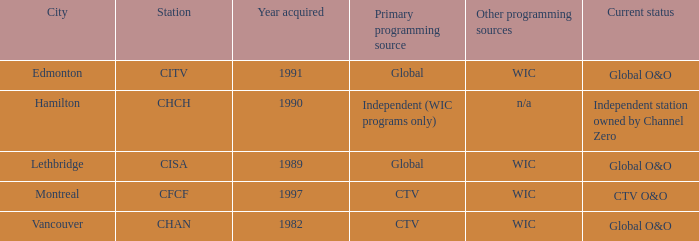How many channels were gained in 1997 1.0. 